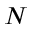Convert formula to latex. <formula><loc_0><loc_0><loc_500><loc_500>N</formula> 